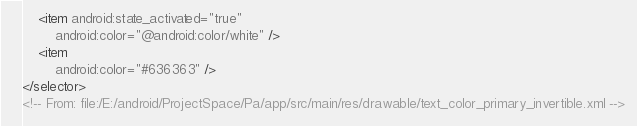<code> <loc_0><loc_0><loc_500><loc_500><_XML_>    <item android:state_activated="true"
        android:color="@android:color/white" />
    <item
        android:color="#636363" />
</selector>
<!-- From: file:/E:/android/ProjectSpace/Pa/app/src/main/res/drawable/text_color_primary_invertible.xml --></code> 